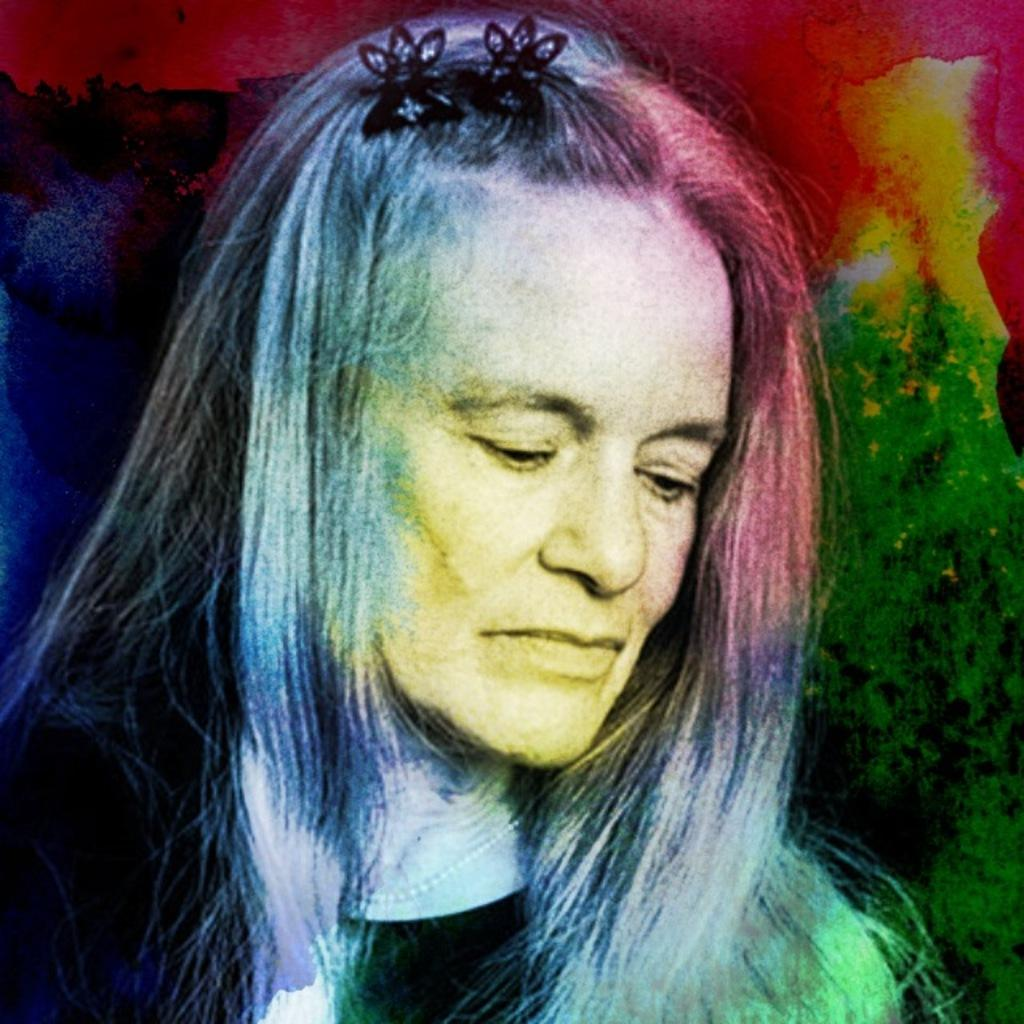What is the main subject of the image? There is an art piece in the image. What can be seen within the art piece? The art piece contains images of people. How can the colors in the art piece be described? There are different colors on the right side of the art piece. What type of drug is being used by the people in the art piece? There is no indication of drug use in the art piece; it only contains images of people. Can you tell me how many yaks are present in the art piece? There are no yaks depicted in the art piece; it features images of people. 